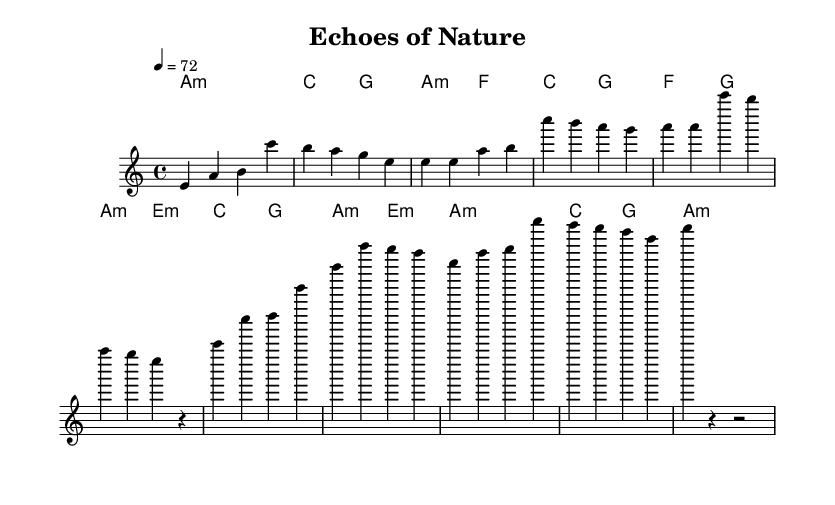What is the key signature of this music? The key signature shows a single flat, indicating that the key is A minor, which has no sharps or flats in its natural form.
Answer: A minor What is the time signature of the piece? The time signature is found at the beginning of the score, displayed as a fraction, indicating that there are four beats in a measure with the quarter note receiving one beat.
Answer: 4/4 What is the tempo marking for this composition? The tempo marking indicates the speed of the music, stating "4 = 72," which means there are 72 quarter-note beats in a minute.
Answer: 72 How many measures are present in the melody section? By counting the groupings of notes separated by vertical bar lines, we can find that there are a total of 12 measures included in the melody section.
Answer: 12 What is the chord progression during the chorus? The chord progression for the chorus can be inferred by looking at the harmony section, specifically at the lines corresponding to the chorus section, which shows the sequence of chords as F, G, A minor, and E minor.
Answer: F, G, A minor, E minor What musical structure is used in this piece? The piece has identifiable sections such as an intro, verse, chorus, bridge, and outro, which collectively form a common structure in pop music.
Answer: Intro, Verse, Chorus, Bridge, Outro What is the dynamic nature of the piece inferred from the score? While dynamics are not explicitly notated in the provided sheet music, the use of field recordings and ambient soundscapes suggests a softer and more atmospheric dynamic, typical of atmospheric indie pop.
Answer: Atmospheric 